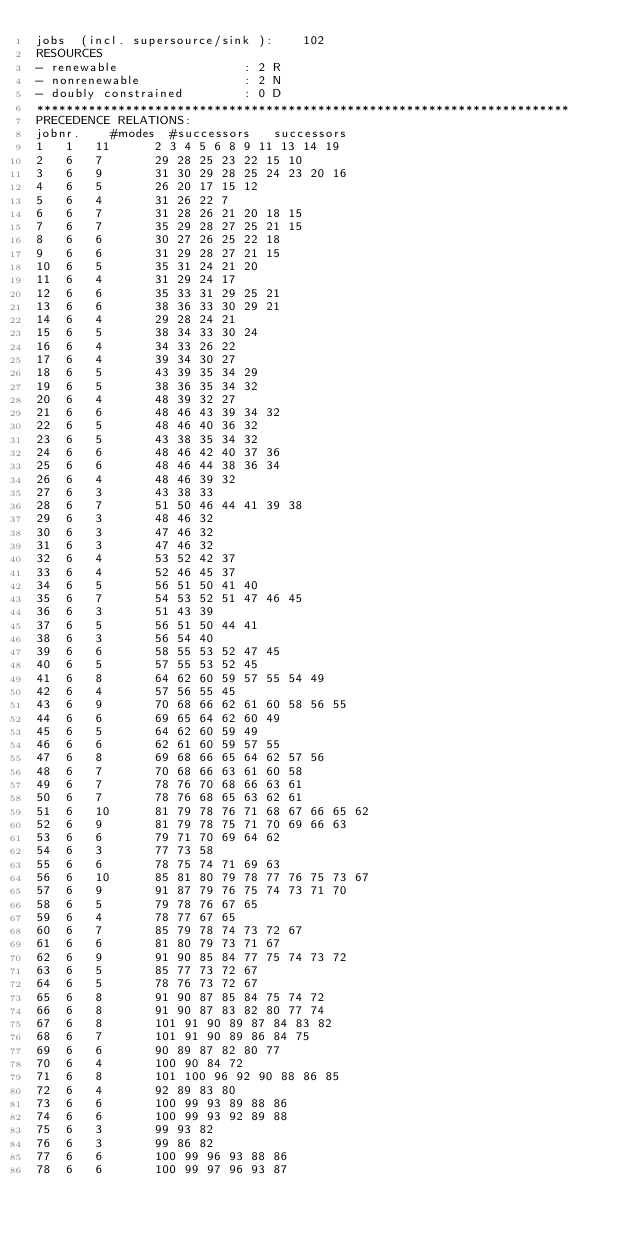Convert code to text. <code><loc_0><loc_0><loc_500><loc_500><_ObjectiveC_>jobs  (incl. supersource/sink ):	102
RESOURCES
- renewable                 : 2 R
- nonrenewable              : 2 N
- doubly constrained        : 0 D
************************************************************************
PRECEDENCE RELATIONS:
jobnr.    #modes  #successors   successors
1	1	11		2 3 4 5 6 8 9 11 13 14 19 
2	6	7		29 28 25 23 22 15 10 
3	6	9		31 30 29 28 25 24 23 20 16 
4	6	5		26 20 17 15 12 
5	6	4		31 26 22 7 
6	6	7		31 28 26 21 20 18 15 
7	6	7		35 29 28 27 25 21 15 
8	6	6		30 27 26 25 22 18 
9	6	6		31 29 28 27 21 15 
10	6	5		35 31 24 21 20 
11	6	4		31 29 24 17 
12	6	6		35 33 31 29 25 21 
13	6	6		38 36 33 30 29 21 
14	6	4		29 28 24 21 
15	6	5		38 34 33 30 24 
16	6	4		34 33 26 22 
17	6	4		39 34 30 27 
18	6	5		43 39 35 34 29 
19	6	5		38 36 35 34 32 
20	6	4		48 39 32 27 
21	6	6		48 46 43 39 34 32 
22	6	5		48 46 40 36 32 
23	6	5		43 38 35 34 32 
24	6	6		48 46 42 40 37 36 
25	6	6		48 46 44 38 36 34 
26	6	4		48 46 39 32 
27	6	3		43 38 33 
28	6	7		51 50 46 44 41 39 38 
29	6	3		48 46 32 
30	6	3		47 46 32 
31	6	3		47 46 32 
32	6	4		53 52 42 37 
33	6	4		52 46 45 37 
34	6	5		56 51 50 41 40 
35	6	7		54 53 52 51 47 46 45 
36	6	3		51 43 39 
37	6	5		56 51 50 44 41 
38	6	3		56 54 40 
39	6	6		58 55 53 52 47 45 
40	6	5		57 55 53 52 45 
41	6	8		64 62 60 59 57 55 54 49 
42	6	4		57 56 55 45 
43	6	9		70 68 66 62 61 60 58 56 55 
44	6	6		69 65 64 62 60 49 
45	6	5		64 62 60 59 49 
46	6	6		62 61 60 59 57 55 
47	6	8		69 68 66 65 64 62 57 56 
48	6	7		70 68 66 63 61 60 58 
49	6	7		78 76 70 68 66 63 61 
50	6	7		78 76 68 65 63 62 61 
51	6	10		81 79 78 76 71 68 67 66 65 62 
52	6	9		81 79 78 75 71 70 69 66 63 
53	6	6		79 71 70 69 64 62 
54	6	3		77 73 58 
55	6	6		78 75 74 71 69 63 
56	6	10		85 81 80 79 78 77 76 75 73 67 
57	6	9		91 87 79 76 75 74 73 71 70 
58	6	5		79 78 76 67 65 
59	6	4		78 77 67 65 
60	6	7		85 79 78 74 73 72 67 
61	6	6		81 80 79 73 71 67 
62	6	9		91 90 85 84 77 75 74 73 72 
63	6	5		85 77 73 72 67 
64	6	5		78 76 73 72 67 
65	6	8		91 90 87 85 84 75 74 72 
66	6	8		91 90 87 83 82 80 77 74 
67	6	8		101 91 90 89 87 84 83 82 
68	6	7		101 91 90 89 86 84 75 
69	6	6		90 89 87 82 80 77 
70	6	4		100 90 84 72 
71	6	8		101 100 96 92 90 88 86 85 
72	6	4		92 89 83 80 
73	6	6		100 99 93 89 88 86 
74	6	6		100 99 93 92 89 88 
75	6	3		99 93 82 
76	6	3		99 86 82 
77	6	6		100 99 96 93 88 86 
78	6	6		100 99 97 96 93 87 </code> 